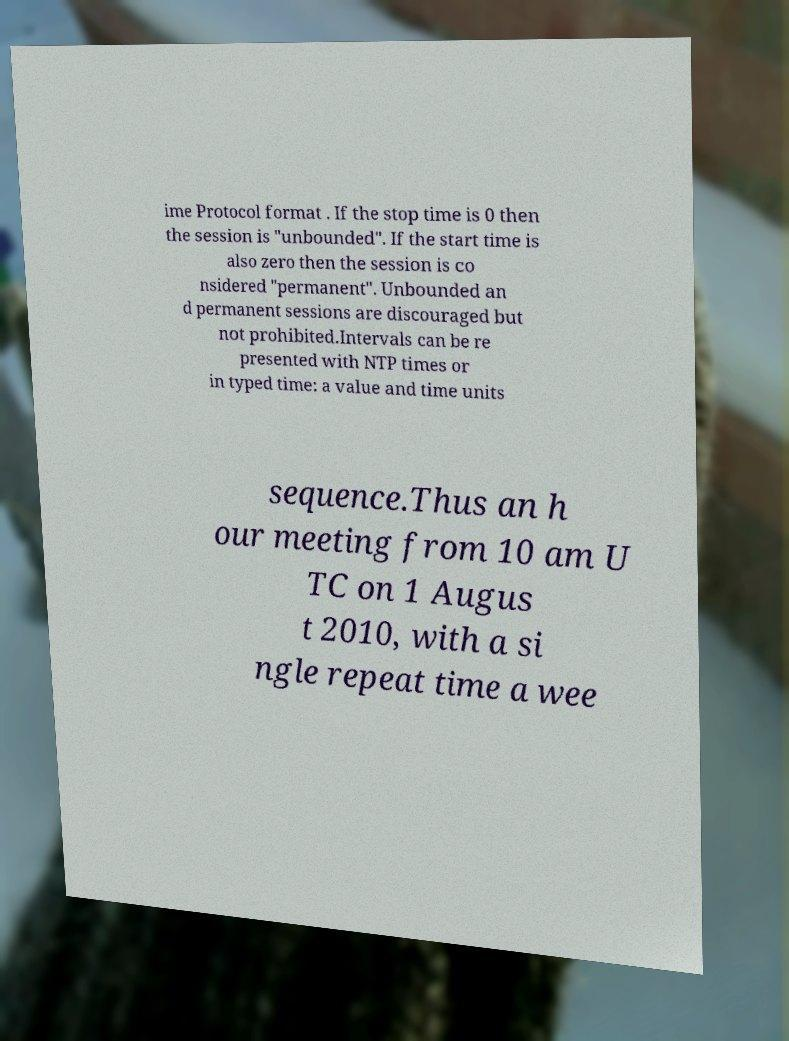I need the written content from this picture converted into text. Can you do that? ime Protocol format . If the stop time is 0 then the session is "unbounded". If the start time is also zero then the session is co nsidered "permanent". Unbounded an d permanent sessions are discouraged but not prohibited.Intervals can be re presented with NTP times or in typed time: a value and time units sequence.Thus an h our meeting from 10 am U TC on 1 Augus t 2010, with a si ngle repeat time a wee 